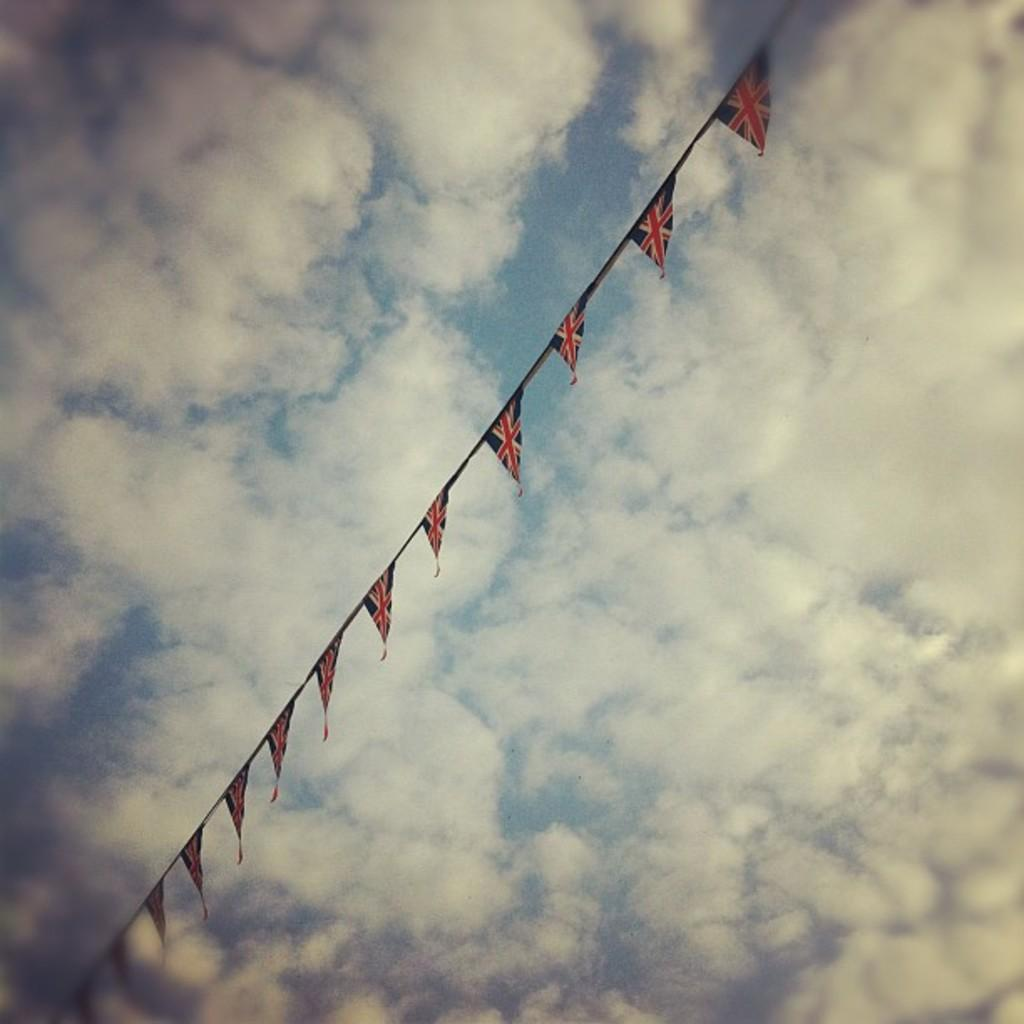What is attached to the rope in the image? There are flags attached to the rope in the image. What can be seen in the background of the image? Sky is visible in the background of the image. What is present in the sky? Clouds are present in the sky. How many units of string are used to tie the chicken in the image? There is no chicken present in the image, and therefore no string is used to tie it. 